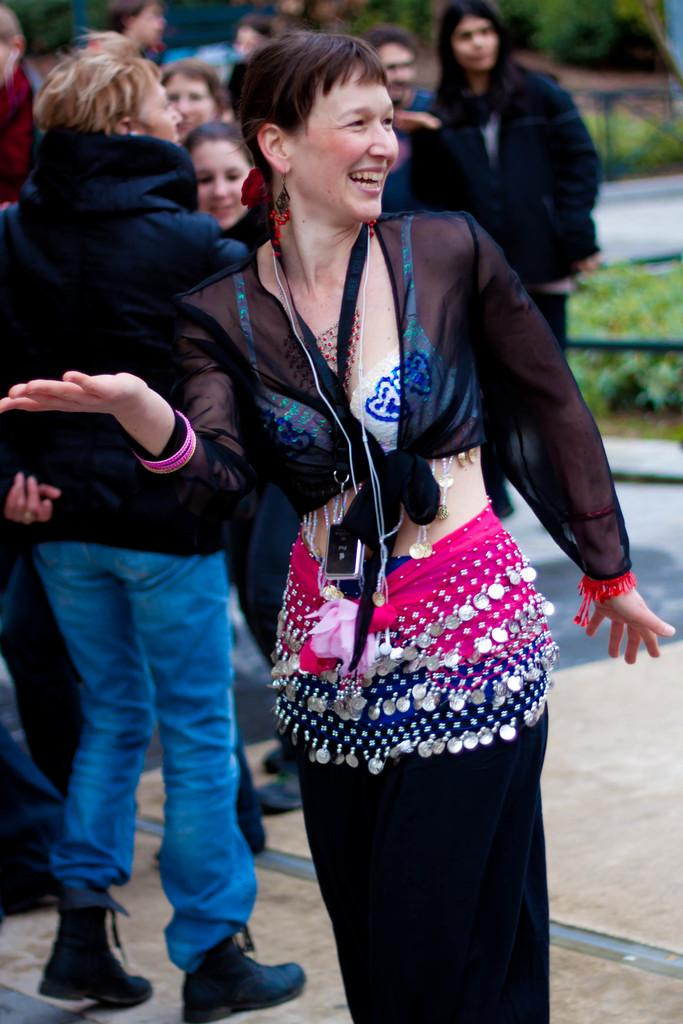Who is the main subject in the image? There is a woman in the middle of the image. What is the woman doing in the image? The woman is smiling. Can you describe the background of the image? There are people in the background of the image. What type of vegetation is on the right side of the image? There are plants on the right side of the image. What type of wood is used to make the chair in the image? There is no chair present in the image. Can you describe the basin in the image? There is no basin present in the image. 